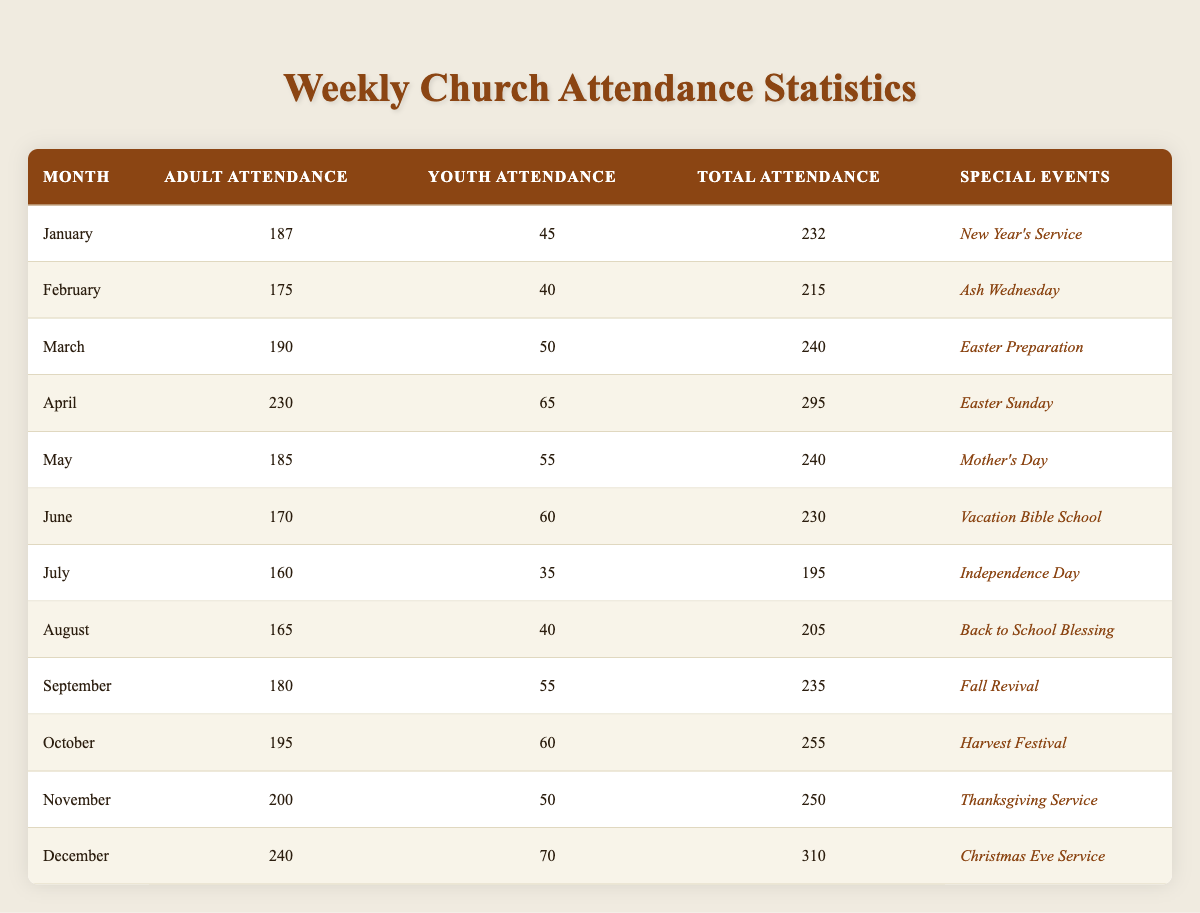What was the highest total attendance in a month? The total attendance is listed for each month, and upon examining the table, December has the highest total attendance at 310.
Answer: 310 In which month did youth attendance drop below 40? Looking through the youth attendance numbers, July is the only month where the attendance dropped below 40 (35).
Answer: July What is the average adult attendance for the first half of the year? To find the average for January to June, we add the adult attendance: 187 + 175 + 190 + 230 + 185 + 170 = 1137. There are 6 months, so the average is 1137 / 6 = 189.5.
Answer: 189.5 Did the total attendance increase from November to December? By comparing the total attendance for November (250) and December (310), we see that the total attendance did increase.
Answer: Yes What was the total attendance for special events during Easter month? Looking at the attendance for March (240) and April (295), we can see that the Easter preparation and Easter Sunday saw a total of 240 + 295 = 535 attending.
Answer: 535 What is the difference in youth attendance between the highest and lowest months? The highest youth attendance was in December with 70 and the lowest was in July with 35. The difference is 70 - 35 = 35.
Answer: 35 Which month had the lowest total attendance? The total attendance for each month shows that July had the lowest attendance with a total of 195.
Answer: July How many special events had a total attendance of over 250? Observing the total attendance numbers, the months with over 250 total attendance are April (295), October (255), November (250), and December (310). Thus, there are 4 instances.
Answer: 4 What was the trend in adult attendance from June to December? Reviewing the adult attendance from June (170) to December (240), we see an increasing trend: 170, 185, 230, 200, and 240, indicating gradual growth overall.
Answer: Increasing trend 